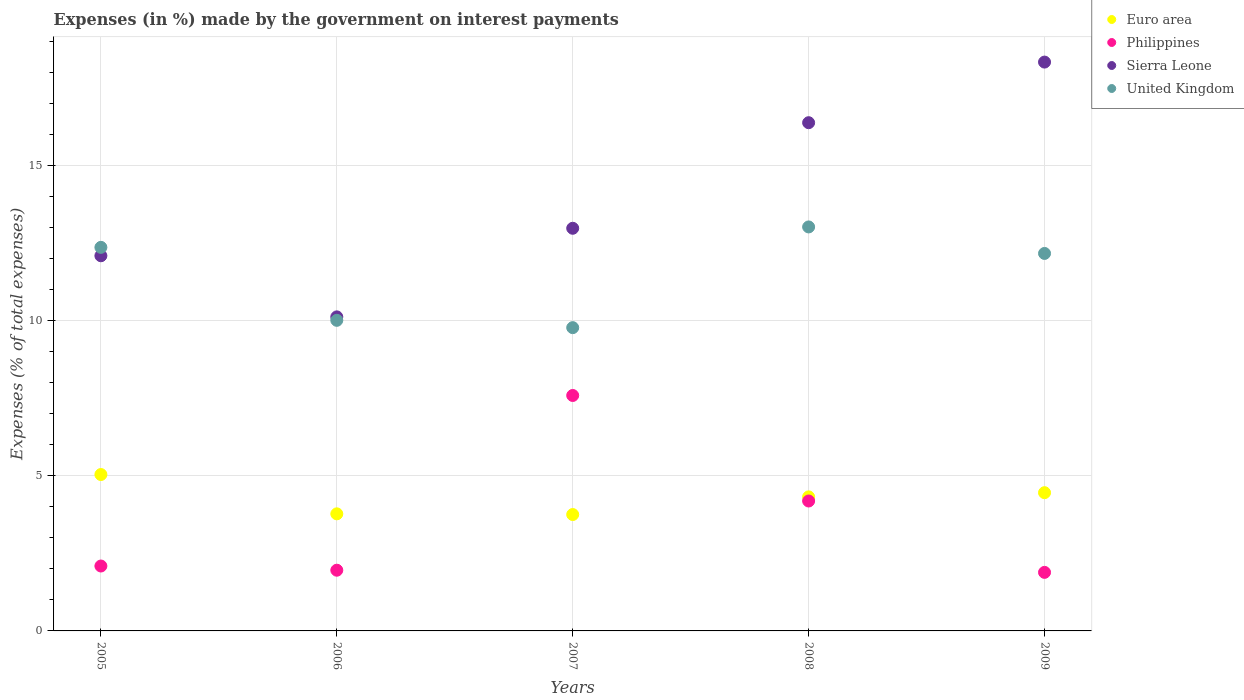What is the percentage of expenses made by the government on interest payments in Sierra Leone in 2007?
Provide a succinct answer. 12.99. Across all years, what is the maximum percentage of expenses made by the government on interest payments in Philippines?
Your answer should be very brief. 7.59. Across all years, what is the minimum percentage of expenses made by the government on interest payments in Euro area?
Offer a very short reply. 3.75. In which year was the percentage of expenses made by the government on interest payments in Philippines maximum?
Give a very brief answer. 2007. In which year was the percentage of expenses made by the government on interest payments in Sierra Leone minimum?
Your answer should be very brief. 2006. What is the total percentage of expenses made by the government on interest payments in Philippines in the graph?
Offer a very short reply. 17.73. What is the difference between the percentage of expenses made by the government on interest payments in Philippines in 2006 and that in 2008?
Ensure brevity in your answer.  -2.23. What is the difference between the percentage of expenses made by the government on interest payments in United Kingdom in 2005 and the percentage of expenses made by the government on interest payments in Sierra Leone in 2007?
Provide a short and direct response. -0.62. What is the average percentage of expenses made by the government on interest payments in Sierra Leone per year?
Offer a terse response. 13.99. In the year 2008, what is the difference between the percentage of expenses made by the government on interest payments in Philippines and percentage of expenses made by the government on interest payments in United Kingdom?
Provide a short and direct response. -8.84. What is the ratio of the percentage of expenses made by the government on interest payments in Sierra Leone in 2006 to that in 2007?
Provide a succinct answer. 0.78. Is the difference between the percentage of expenses made by the government on interest payments in Philippines in 2005 and 2006 greater than the difference between the percentage of expenses made by the government on interest payments in United Kingdom in 2005 and 2006?
Provide a succinct answer. No. What is the difference between the highest and the second highest percentage of expenses made by the government on interest payments in Philippines?
Your answer should be very brief. 3.4. What is the difference between the highest and the lowest percentage of expenses made by the government on interest payments in Euro area?
Provide a short and direct response. 1.29. In how many years, is the percentage of expenses made by the government on interest payments in United Kingdom greater than the average percentage of expenses made by the government on interest payments in United Kingdom taken over all years?
Provide a succinct answer. 3. Is the sum of the percentage of expenses made by the government on interest payments in Euro area in 2006 and 2009 greater than the maximum percentage of expenses made by the government on interest payments in Sierra Leone across all years?
Make the answer very short. No. Is it the case that in every year, the sum of the percentage of expenses made by the government on interest payments in Sierra Leone and percentage of expenses made by the government on interest payments in United Kingdom  is greater than the percentage of expenses made by the government on interest payments in Philippines?
Ensure brevity in your answer.  Yes. Does the percentage of expenses made by the government on interest payments in Sierra Leone monotonically increase over the years?
Provide a short and direct response. No. Is the percentage of expenses made by the government on interest payments in Sierra Leone strictly greater than the percentage of expenses made by the government on interest payments in Philippines over the years?
Give a very brief answer. Yes. How many years are there in the graph?
Keep it short and to the point. 5. Are the values on the major ticks of Y-axis written in scientific E-notation?
Your answer should be very brief. No. Does the graph contain any zero values?
Your response must be concise. No. How are the legend labels stacked?
Ensure brevity in your answer.  Vertical. What is the title of the graph?
Your answer should be compact. Expenses (in %) made by the government on interest payments. Does "Austria" appear as one of the legend labels in the graph?
Provide a short and direct response. No. What is the label or title of the Y-axis?
Your response must be concise. Expenses (% of total expenses). What is the Expenses (% of total expenses) in Euro area in 2005?
Offer a very short reply. 5.04. What is the Expenses (% of total expenses) of Philippines in 2005?
Provide a succinct answer. 2.09. What is the Expenses (% of total expenses) in Sierra Leone in 2005?
Your response must be concise. 12.1. What is the Expenses (% of total expenses) of United Kingdom in 2005?
Make the answer very short. 12.37. What is the Expenses (% of total expenses) of Euro area in 2006?
Offer a very short reply. 3.78. What is the Expenses (% of total expenses) in Philippines in 2006?
Ensure brevity in your answer.  1.96. What is the Expenses (% of total expenses) in Sierra Leone in 2006?
Offer a terse response. 10.13. What is the Expenses (% of total expenses) in United Kingdom in 2006?
Provide a short and direct response. 10.02. What is the Expenses (% of total expenses) of Euro area in 2007?
Offer a terse response. 3.75. What is the Expenses (% of total expenses) of Philippines in 2007?
Provide a succinct answer. 7.59. What is the Expenses (% of total expenses) of Sierra Leone in 2007?
Offer a terse response. 12.99. What is the Expenses (% of total expenses) in United Kingdom in 2007?
Ensure brevity in your answer.  9.78. What is the Expenses (% of total expenses) in Euro area in 2008?
Ensure brevity in your answer.  4.32. What is the Expenses (% of total expenses) in Philippines in 2008?
Provide a succinct answer. 4.19. What is the Expenses (% of total expenses) of Sierra Leone in 2008?
Provide a short and direct response. 16.39. What is the Expenses (% of total expenses) in United Kingdom in 2008?
Give a very brief answer. 13.03. What is the Expenses (% of total expenses) of Euro area in 2009?
Provide a succinct answer. 4.46. What is the Expenses (% of total expenses) of Philippines in 2009?
Provide a succinct answer. 1.89. What is the Expenses (% of total expenses) in Sierra Leone in 2009?
Ensure brevity in your answer.  18.35. What is the Expenses (% of total expenses) of United Kingdom in 2009?
Your response must be concise. 12.18. Across all years, what is the maximum Expenses (% of total expenses) in Euro area?
Your answer should be very brief. 5.04. Across all years, what is the maximum Expenses (% of total expenses) in Philippines?
Make the answer very short. 7.59. Across all years, what is the maximum Expenses (% of total expenses) of Sierra Leone?
Offer a terse response. 18.35. Across all years, what is the maximum Expenses (% of total expenses) in United Kingdom?
Give a very brief answer. 13.03. Across all years, what is the minimum Expenses (% of total expenses) in Euro area?
Your answer should be very brief. 3.75. Across all years, what is the minimum Expenses (% of total expenses) of Philippines?
Make the answer very short. 1.89. Across all years, what is the minimum Expenses (% of total expenses) of Sierra Leone?
Ensure brevity in your answer.  10.13. Across all years, what is the minimum Expenses (% of total expenses) in United Kingdom?
Give a very brief answer. 9.78. What is the total Expenses (% of total expenses) in Euro area in the graph?
Ensure brevity in your answer.  21.36. What is the total Expenses (% of total expenses) of Philippines in the graph?
Provide a short and direct response. 17.73. What is the total Expenses (% of total expenses) of Sierra Leone in the graph?
Your answer should be very brief. 69.96. What is the total Expenses (% of total expenses) of United Kingdom in the graph?
Your response must be concise. 57.38. What is the difference between the Expenses (% of total expenses) in Euro area in 2005 and that in 2006?
Provide a short and direct response. 1.27. What is the difference between the Expenses (% of total expenses) in Philippines in 2005 and that in 2006?
Ensure brevity in your answer.  0.14. What is the difference between the Expenses (% of total expenses) in Sierra Leone in 2005 and that in 2006?
Provide a succinct answer. 1.97. What is the difference between the Expenses (% of total expenses) in United Kingdom in 2005 and that in 2006?
Ensure brevity in your answer.  2.35. What is the difference between the Expenses (% of total expenses) of Euro area in 2005 and that in 2007?
Keep it short and to the point. 1.29. What is the difference between the Expenses (% of total expenses) of Philippines in 2005 and that in 2007?
Ensure brevity in your answer.  -5.5. What is the difference between the Expenses (% of total expenses) of Sierra Leone in 2005 and that in 2007?
Provide a succinct answer. -0.89. What is the difference between the Expenses (% of total expenses) in United Kingdom in 2005 and that in 2007?
Offer a terse response. 2.59. What is the difference between the Expenses (% of total expenses) in Euro area in 2005 and that in 2008?
Ensure brevity in your answer.  0.72. What is the difference between the Expenses (% of total expenses) of Philippines in 2005 and that in 2008?
Your answer should be compact. -2.1. What is the difference between the Expenses (% of total expenses) of Sierra Leone in 2005 and that in 2008?
Give a very brief answer. -4.29. What is the difference between the Expenses (% of total expenses) of United Kingdom in 2005 and that in 2008?
Ensure brevity in your answer.  -0.66. What is the difference between the Expenses (% of total expenses) in Euro area in 2005 and that in 2009?
Offer a terse response. 0.59. What is the difference between the Expenses (% of total expenses) in Philippines in 2005 and that in 2009?
Offer a very short reply. 0.2. What is the difference between the Expenses (% of total expenses) in Sierra Leone in 2005 and that in 2009?
Your response must be concise. -6.25. What is the difference between the Expenses (% of total expenses) in United Kingdom in 2005 and that in 2009?
Give a very brief answer. 0.2. What is the difference between the Expenses (% of total expenses) of Euro area in 2006 and that in 2007?
Ensure brevity in your answer.  0.02. What is the difference between the Expenses (% of total expenses) in Philippines in 2006 and that in 2007?
Your answer should be very brief. -5.64. What is the difference between the Expenses (% of total expenses) in Sierra Leone in 2006 and that in 2007?
Ensure brevity in your answer.  -2.86. What is the difference between the Expenses (% of total expenses) in United Kingdom in 2006 and that in 2007?
Provide a succinct answer. 0.24. What is the difference between the Expenses (% of total expenses) in Euro area in 2006 and that in 2008?
Your answer should be very brief. -0.55. What is the difference between the Expenses (% of total expenses) of Philippines in 2006 and that in 2008?
Your answer should be compact. -2.23. What is the difference between the Expenses (% of total expenses) in Sierra Leone in 2006 and that in 2008?
Provide a short and direct response. -6.26. What is the difference between the Expenses (% of total expenses) of United Kingdom in 2006 and that in 2008?
Offer a very short reply. -3.01. What is the difference between the Expenses (% of total expenses) in Euro area in 2006 and that in 2009?
Keep it short and to the point. -0.68. What is the difference between the Expenses (% of total expenses) of Philippines in 2006 and that in 2009?
Offer a terse response. 0.07. What is the difference between the Expenses (% of total expenses) in Sierra Leone in 2006 and that in 2009?
Your answer should be compact. -8.22. What is the difference between the Expenses (% of total expenses) in United Kingdom in 2006 and that in 2009?
Keep it short and to the point. -2.16. What is the difference between the Expenses (% of total expenses) of Euro area in 2007 and that in 2008?
Make the answer very short. -0.57. What is the difference between the Expenses (% of total expenses) of Philippines in 2007 and that in 2008?
Offer a terse response. 3.4. What is the difference between the Expenses (% of total expenses) in Sierra Leone in 2007 and that in 2008?
Make the answer very short. -3.41. What is the difference between the Expenses (% of total expenses) of United Kingdom in 2007 and that in 2008?
Your answer should be compact. -3.25. What is the difference between the Expenses (% of total expenses) of Euro area in 2007 and that in 2009?
Provide a succinct answer. -0.7. What is the difference between the Expenses (% of total expenses) in Philippines in 2007 and that in 2009?
Offer a very short reply. 5.71. What is the difference between the Expenses (% of total expenses) of Sierra Leone in 2007 and that in 2009?
Make the answer very short. -5.36. What is the difference between the Expenses (% of total expenses) of United Kingdom in 2007 and that in 2009?
Provide a succinct answer. -2.39. What is the difference between the Expenses (% of total expenses) of Euro area in 2008 and that in 2009?
Provide a short and direct response. -0.13. What is the difference between the Expenses (% of total expenses) in Philippines in 2008 and that in 2009?
Your answer should be compact. 2.3. What is the difference between the Expenses (% of total expenses) of Sierra Leone in 2008 and that in 2009?
Give a very brief answer. -1.96. What is the difference between the Expenses (% of total expenses) in United Kingdom in 2008 and that in 2009?
Your answer should be compact. 0.85. What is the difference between the Expenses (% of total expenses) of Euro area in 2005 and the Expenses (% of total expenses) of Philippines in 2006?
Your answer should be very brief. 3.09. What is the difference between the Expenses (% of total expenses) of Euro area in 2005 and the Expenses (% of total expenses) of Sierra Leone in 2006?
Your answer should be compact. -5.09. What is the difference between the Expenses (% of total expenses) of Euro area in 2005 and the Expenses (% of total expenses) of United Kingdom in 2006?
Offer a terse response. -4.97. What is the difference between the Expenses (% of total expenses) in Philippines in 2005 and the Expenses (% of total expenses) in Sierra Leone in 2006?
Offer a terse response. -8.04. What is the difference between the Expenses (% of total expenses) of Philippines in 2005 and the Expenses (% of total expenses) of United Kingdom in 2006?
Ensure brevity in your answer.  -7.92. What is the difference between the Expenses (% of total expenses) in Sierra Leone in 2005 and the Expenses (% of total expenses) in United Kingdom in 2006?
Offer a terse response. 2.08. What is the difference between the Expenses (% of total expenses) of Euro area in 2005 and the Expenses (% of total expenses) of Philippines in 2007?
Ensure brevity in your answer.  -2.55. What is the difference between the Expenses (% of total expenses) in Euro area in 2005 and the Expenses (% of total expenses) in Sierra Leone in 2007?
Give a very brief answer. -7.94. What is the difference between the Expenses (% of total expenses) of Euro area in 2005 and the Expenses (% of total expenses) of United Kingdom in 2007?
Ensure brevity in your answer.  -4.74. What is the difference between the Expenses (% of total expenses) of Philippines in 2005 and the Expenses (% of total expenses) of Sierra Leone in 2007?
Keep it short and to the point. -10.89. What is the difference between the Expenses (% of total expenses) of Philippines in 2005 and the Expenses (% of total expenses) of United Kingdom in 2007?
Keep it short and to the point. -7.69. What is the difference between the Expenses (% of total expenses) of Sierra Leone in 2005 and the Expenses (% of total expenses) of United Kingdom in 2007?
Your answer should be very brief. 2.32. What is the difference between the Expenses (% of total expenses) of Euro area in 2005 and the Expenses (% of total expenses) of Philippines in 2008?
Offer a very short reply. 0.85. What is the difference between the Expenses (% of total expenses) in Euro area in 2005 and the Expenses (% of total expenses) in Sierra Leone in 2008?
Ensure brevity in your answer.  -11.35. What is the difference between the Expenses (% of total expenses) of Euro area in 2005 and the Expenses (% of total expenses) of United Kingdom in 2008?
Your response must be concise. -7.99. What is the difference between the Expenses (% of total expenses) in Philippines in 2005 and the Expenses (% of total expenses) in Sierra Leone in 2008?
Make the answer very short. -14.3. What is the difference between the Expenses (% of total expenses) in Philippines in 2005 and the Expenses (% of total expenses) in United Kingdom in 2008?
Your response must be concise. -10.94. What is the difference between the Expenses (% of total expenses) in Sierra Leone in 2005 and the Expenses (% of total expenses) in United Kingdom in 2008?
Ensure brevity in your answer.  -0.93. What is the difference between the Expenses (% of total expenses) in Euro area in 2005 and the Expenses (% of total expenses) in Philippines in 2009?
Offer a very short reply. 3.16. What is the difference between the Expenses (% of total expenses) of Euro area in 2005 and the Expenses (% of total expenses) of Sierra Leone in 2009?
Make the answer very short. -13.3. What is the difference between the Expenses (% of total expenses) of Euro area in 2005 and the Expenses (% of total expenses) of United Kingdom in 2009?
Make the answer very short. -7.13. What is the difference between the Expenses (% of total expenses) of Philippines in 2005 and the Expenses (% of total expenses) of Sierra Leone in 2009?
Make the answer very short. -16.25. What is the difference between the Expenses (% of total expenses) in Philippines in 2005 and the Expenses (% of total expenses) in United Kingdom in 2009?
Offer a very short reply. -10.08. What is the difference between the Expenses (% of total expenses) in Sierra Leone in 2005 and the Expenses (% of total expenses) in United Kingdom in 2009?
Offer a very short reply. -0.07. What is the difference between the Expenses (% of total expenses) of Euro area in 2006 and the Expenses (% of total expenses) of Philippines in 2007?
Give a very brief answer. -3.82. What is the difference between the Expenses (% of total expenses) in Euro area in 2006 and the Expenses (% of total expenses) in Sierra Leone in 2007?
Your answer should be compact. -9.21. What is the difference between the Expenses (% of total expenses) of Euro area in 2006 and the Expenses (% of total expenses) of United Kingdom in 2007?
Your answer should be compact. -6.01. What is the difference between the Expenses (% of total expenses) of Philippines in 2006 and the Expenses (% of total expenses) of Sierra Leone in 2007?
Provide a short and direct response. -11.03. What is the difference between the Expenses (% of total expenses) of Philippines in 2006 and the Expenses (% of total expenses) of United Kingdom in 2007?
Make the answer very short. -7.82. What is the difference between the Expenses (% of total expenses) of Sierra Leone in 2006 and the Expenses (% of total expenses) of United Kingdom in 2007?
Your answer should be very brief. 0.35. What is the difference between the Expenses (% of total expenses) of Euro area in 2006 and the Expenses (% of total expenses) of Philippines in 2008?
Provide a short and direct response. -0.41. What is the difference between the Expenses (% of total expenses) in Euro area in 2006 and the Expenses (% of total expenses) in Sierra Leone in 2008?
Keep it short and to the point. -12.62. What is the difference between the Expenses (% of total expenses) in Euro area in 2006 and the Expenses (% of total expenses) in United Kingdom in 2008?
Offer a very short reply. -9.25. What is the difference between the Expenses (% of total expenses) in Philippines in 2006 and the Expenses (% of total expenses) in Sierra Leone in 2008?
Ensure brevity in your answer.  -14.43. What is the difference between the Expenses (% of total expenses) in Philippines in 2006 and the Expenses (% of total expenses) in United Kingdom in 2008?
Give a very brief answer. -11.07. What is the difference between the Expenses (% of total expenses) of Sierra Leone in 2006 and the Expenses (% of total expenses) of United Kingdom in 2008?
Make the answer very short. -2.9. What is the difference between the Expenses (% of total expenses) of Euro area in 2006 and the Expenses (% of total expenses) of Philippines in 2009?
Give a very brief answer. 1.89. What is the difference between the Expenses (% of total expenses) in Euro area in 2006 and the Expenses (% of total expenses) in Sierra Leone in 2009?
Your answer should be very brief. -14.57. What is the difference between the Expenses (% of total expenses) of Euro area in 2006 and the Expenses (% of total expenses) of United Kingdom in 2009?
Your answer should be very brief. -8.4. What is the difference between the Expenses (% of total expenses) in Philippines in 2006 and the Expenses (% of total expenses) in Sierra Leone in 2009?
Give a very brief answer. -16.39. What is the difference between the Expenses (% of total expenses) of Philippines in 2006 and the Expenses (% of total expenses) of United Kingdom in 2009?
Your answer should be very brief. -10.22. What is the difference between the Expenses (% of total expenses) of Sierra Leone in 2006 and the Expenses (% of total expenses) of United Kingdom in 2009?
Provide a short and direct response. -2.05. What is the difference between the Expenses (% of total expenses) in Euro area in 2007 and the Expenses (% of total expenses) in Philippines in 2008?
Offer a terse response. -0.44. What is the difference between the Expenses (% of total expenses) of Euro area in 2007 and the Expenses (% of total expenses) of Sierra Leone in 2008?
Your answer should be very brief. -12.64. What is the difference between the Expenses (% of total expenses) of Euro area in 2007 and the Expenses (% of total expenses) of United Kingdom in 2008?
Make the answer very short. -9.28. What is the difference between the Expenses (% of total expenses) of Philippines in 2007 and the Expenses (% of total expenses) of Sierra Leone in 2008?
Keep it short and to the point. -8.8. What is the difference between the Expenses (% of total expenses) of Philippines in 2007 and the Expenses (% of total expenses) of United Kingdom in 2008?
Your answer should be very brief. -5.44. What is the difference between the Expenses (% of total expenses) in Sierra Leone in 2007 and the Expenses (% of total expenses) in United Kingdom in 2008?
Your response must be concise. -0.04. What is the difference between the Expenses (% of total expenses) of Euro area in 2007 and the Expenses (% of total expenses) of Philippines in 2009?
Make the answer very short. 1.87. What is the difference between the Expenses (% of total expenses) of Euro area in 2007 and the Expenses (% of total expenses) of Sierra Leone in 2009?
Your answer should be very brief. -14.59. What is the difference between the Expenses (% of total expenses) in Euro area in 2007 and the Expenses (% of total expenses) in United Kingdom in 2009?
Keep it short and to the point. -8.42. What is the difference between the Expenses (% of total expenses) in Philippines in 2007 and the Expenses (% of total expenses) in Sierra Leone in 2009?
Make the answer very short. -10.75. What is the difference between the Expenses (% of total expenses) of Philippines in 2007 and the Expenses (% of total expenses) of United Kingdom in 2009?
Give a very brief answer. -4.58. What is the difference between the Expenses (% of total expenses) of Sierra Leone in 2007 and the Expenses (% of total expenses) of United Kingdom in 2009?
Offer a terse response. 0.81. What is the difference between the Expenses (% of total expenses) of Euro area in 2008 and the Expenses (% of total expenses) of Philippines in 2009?
Make the answer very short. 2.44. What is the difference between the Expenses (% of total expenses) in Euro area in 2008 and the Expenses (% of total expenses) in Sierra Leone in 2009?
Ensure brevity in your answer.  -14.02. What is the difference between the Expenses (% of total expenses) of Euro area in 2008 and the Expenses (% of total expenses) of United Kingdom in 2009?
Your answer should be compact. -7.85. What is the difference between the Expenses (% of total expenses) of Philippines in 2008 and the Expenses (% of total expenses) of Sierra Leone in 2009?
Give a very brief answer. -14.16. What is the difference between the Expenses (% of total expenses) of Philippines in 2008 and the Expenses (% of total expenses) of United Kingdom in 2009?
Offer a very short reply. -7.99. What is the difference between the Expenses (% of total expenses) in Sierra Leone in 2008 and the Expenses (% of total expenses) in United Kingdom in 2009?
Provide a succinct answer. 4.22. What is the average Expenses (% of total expenses) of Euro area per year?
Provide a short and direct response. 4.27. What is the average Expenses (% of total expenses) of Philippines per year?
Provide a succinct answer. 3.55. What is the average Expenses (% of total expenses) in Sierra Leone per year?
Offer a terse response. 13.99. What is the average Expenses (% of total expenses) in United Kingdom per year?
Give a very brief answer. 11.48. In the year 2005, what is the difference between the Expenses (% of total expenses) of Euro area and Expenses (% of total expenses) of Philippines?
Offer a terse response. 2.95. In the year 2005, what is the difference between the Expenses (% of total expenses) of Euro area and Expenses (% of total expenses) of Sierra Leone?
Your answer should be very brief. -7.06. In the year 2005, what is the difference between the Expenses (% of total expenses) in Euro area and Expenses (% of total expenses) in United Kingdom?
Provide a succinct answer. -7.33. In the year 2005, what is the difference between the Expenses (% of total expenses) in Philippines and Expenses (% of total expenses) in Sierra Leone?
Ensure brevity in your answer.  -10.01. In the year 2005, what is the difference between the Expenses (% of total expenses) in Philippines and Expenses (% of total expenses) in United Kingdom?
Your answer should be compact. -10.28. In the year 2005, what is the difference between the Expenses (% of total expenses) in Sierra Leone and Expenses (% of total expenses) in United Kingdom?
Provide a succinct answer. -0.27. In the year 2006, what is the difference between the Expenses (% of total expenses) in Euro area and Expenses (% of total expenses) in Philippines?
Give a very brief answer. 1.82. In the year 2006, what is the difference between the Expenses (% of total expenses) in Euro area and Expenses (% of total expenses) in Sierra Leone?
Provide a short and direct response. -6.35. In the year 2006, what is the difference between the Expenses (% of total expenses) in Euro area and Expenses (% of total expenses) in United Kingdom?
Provide a succinct answer. -6.24. In the year 2006, what is the difference between the Expenses (% of total expenses) in Philippines and Expenses (% of total expenses) in Sierra Leone?
Your answer should be compact. -8.17. In the year 2006, what is the difference between the Expenses (% of total expenses) of Philippines and Expenses (% of total expenses) of United Kingdom?
Your response must be concise. -8.06. In the year 2006, what is the difference between the Expenses (% of total expenses) of Sierra Leone and Expenses (% of total expenses) of United Kingdom?
Provide a succinct answer. 0.11. In the year 2007, what is the difference between the Expenses (% of total expenses) of Euro area and Expenses (% of total expenses) of Philippines?
Ensure brevity in your answer.  -3.84. In the year 2007, what is the difference between the Expenses (% of total expenses) in Euro area and Expenses (% of total expenses) in Sierra Leone?
Your answer should be compact. -9.23. In the year 2007, what is the difference between the Expenses (% of total expenses) of Euro area and Expenses (% of total expenses) of United Kingdom?
Keep it short and to the point. -6.03. In the year 2007, what is the difference between the Expenses (% of total expenses) of Philippines and Expenses (% of total expenses) of Sierra Leone?
Provide a short and direct response. -5.39. In the year 2007, what is the difference between the Expenses (% of total expenses) in Philippines and Expenses (% of total expenses) in United Kingdom?
Give a very brief answer. -2.19. In the year 2007, what is the difference between the Expenses (% of total expenses) of Sierra Leone and Expenses (% of total expenses) of United Kingdom?
Ensure brevity in your answer.  3.21. In the year 2008, what is the difference between the Expenses (% of total expenses) in Euro area and Expenses (% of total expenses) in Philippines?
Make the answer very short. 0.13. In the year 2008, what is the difference between the Expenses (% of total expenses) of Euro area and Expenses (% of total expenses) of Sierra Leone?
Give a very brief answer. -12.07. In the year 2008, what is the difference between the Expenses (% of total expenses) in Euro area and Expenses (% of total expenses) in United Kingdom?
Offer a terse response. -8.71. In the year 2008, what is the difference between the Expenses (% of total expenses) of Philippines and Expenses (% of total expenses) of Sierra Leone?
Make the answer very short. -12.2. In the year 2008, what is the difference between the Expenses (% of total expenses) in Philippines and Expenses (% of total expenses) in United Kingdom?
Give a very brief answer. -8.84. In the year 2008, what is the difference between the Expenses (% of total expenses) in Sierra Leone and Expenses (% of total expenses) in United Kingdom?
Offer a very short reply. 3.36. In the year 2009, what is the difference between the Expenses (% of total expenses) in Euro area and Expenses (% of total expenses) in Philippines?
Your answer should be very brief. 2.57. In the year 2009, what is the difference between the Expenses (% of total expenses) of Euro area and Expenses (% of total expenses) of Sierra Leone?
Make the answer very short. -13.89. In the year 2009, what is the difference between the Expenses (% of total expenses) of Euro area and Expenses (% of total expenses) of United Kingdom?
Keep it short and to the point. -7.72. In the year 2009, what is the difference between the Expenses (% of total expenses) of Philippines and Expenses (% of total expenses) of Sierra Leone?
Make the answer very short. -16.46. In the year 2009, what is the difference between the Expenses (% of total expenses) in Philippines and Expenses (% of total expenses) in United Kingdom?
Make the answer very short. -10.29. In the year 2009, what is the difference between the Expenses (% of total expenses) of Sierra Leone and Expenses (% of total expenses) of United Kingdom?
Offer a very short reply. 6.17. What is the ratio of the Expenses (% of total expenses) of Euro area in 2005 to that in 2006?
Your answer should be compact. 1.34. What is the ratio of the Expenses (% of total expenses) of Philippines in 2005 to that in 2006?
Offer a terse response. 1.07. What is the ratio of the Expenses (% of total expenses) in Sierra Leone in 2005 to that in 2006?
Your answer should be compact. 1.19. What is the ratio of the Expenses (% of total expenses) of United Kingdom in 2005 to that in 2006?
Your answer should be very brief. 1.23. What is the ratio of the Expenses (% of total expenses) of Euro area in 2005 to that in 2007?
Your answer should be compact. 1.34. What is the ratio of the Expenses (% of total expenses) of Philippines in 2005 to that in 2007?
Make the answer very short. 0.28. What is the ratio of the Expenses (% of total expenses) in Sierra Leone in 2005 to that in 2007?
Offer a very short reply. 0.93. What is the ratio of the Expenses (% of total expenses) of United Kingdom in 2005 to that in 2007?
Offer a terse response. 1.26. What is the ratio of the Expenses (% of total expenses) of Euro area in 2005 to that in 2008?
Your answer should be compact. 1.17. What is the ratio of the Expenses (% of total expenses) in Philippines in 2005 to that in 2008?
Offer a terse response. 0.5. What is the ratio of the Expenses (% of total expenses) in Sierra Leone in 2005 to that in 2008?
Your response must be concise. 0.74. What is the ratio of the Expenses (% of total expenses) of United Kingdom in 2005 to that in 2008?
Give a very brief answer. 0.95. What is the ratio of the Expenses (% of total expenses) in Euro area in 2005 to that in 2009?
Your response must be concise. 1.13. What is the ratio of the Expenses (% of total expenses) in Philippines in 2005 to that in 2009?
Provide a short and direct response. 1.11. What is the ratio of the Expenses (% of total expenses) of Sierra Leone in 2005 to that in 2009?
Your answer should be compact. 0.66. What is the ratio of the Expenses (% of total expenses) of United Kingdom in 2005 to that in 2009?
Provide a short and direct response. 1.02. What is the ratio of the Expenses (% of total expenses) of Philippines in 2006 to that in 2007?
Your answer should be very brief. 0.26. What is the ratio of the Expenses (% of total expenses) of Sierra Leone in 2006 to that in 2007?
Your answer should be very brief. 0.78. What is the ratio of the Expenses (% of total expenses) in United Kingdom in 2006 to that in 2007?
Ensure brevity in your answer.  1.02. What is the ratio of the Expenses (% of total expenses) of Euro area in 2006 to that in 2008?
Offer a very short reply. 0.87. What is the ratio of the Expenses (% of total expenses) in Philippines in 2006 to that in 2008?
Ensure brevity in your answer.  0.47. What is the ratio of the Expenses (% of total expenses) in Sierra Leone in 2006 to that in 2008?
Ensure brevity in your answer.  0.62. What is the ratio of the Expenses (% of total expenses) of United Kingdom in 2006 to that in 2008?
Offer a terse response. 0.77. What is the ratio of the Expenses (% of total expenses) in Euro area in 2006 to that in 2009?
Your answer should be compact. 0.85. What is the ratio of the Expenses (% of total expenses) of Sierra Leone in 2006 to that in 2009?
Offer a terse response. 0.55. What is the ratio of the Expenses (% of total expenses) in United Kingdom in 2006 to that in 2009?
Provide a short and direct response. 0.82. What is the ratio of the Expenses (% of total expenses) in Euro area in 2007 to that in 2008?
Provide a short and direct response. 0.87. What is the ratio of the Expenses (% of total expenses) in Philippines in 2007 to that in 2008?
Offer a terse response. 1.81. What is the ratio of the Expenses (% of total expenses) of Sierra Leone in 2007 to that in 2008?
Your answer should be very brief. 0.79. What is the ratio of the Expenses (% of total expenses) in United Kingdom in 2007 to that in 2008?
Give a very brief answer. 0.75. What is the ratio of the Expenses (% of total expenses) of Euro area in 2007 to that in 2009?
Offer a very short reply. 0.84. What is the ratio of the Expenses (% of total expenses) in Philippines in 2007 to that in 2009?
Provide a succinct answer. 4.02. What is the ratio of the Expenses (% of total expenses) in Sierra Leone in 2007 to that in 2009?
Keep it short and to the point. 0.71. What is the ratio of the Expenses (% of total expenses) of United Kingdom in 2007 to that in 2009?
Provide a short and direct response. 0.8. What is the ratio of the Expenses (% of total expenses) of Euro area in 2008 to that in 2009?
Your response must be concise. 0.97. What is the ratio of the Expenses (% of total expenses) of Philippines in 2008 to that in 2009?
Offer a terse response. 2.22. What is the ratio of the Expenses (% of total expenses) in Sierra Leone in 2008 to that in 2009?
Make the answer very short. 0.89. What is the ratio of the Expenses (% of total expenses) of United Kingdom in 2008 to that in 2009?
Offer a very short reply. 1.07. What is the difference between the highest and the second highest Expenses (% of total expenses) of Euro area?
Your answer should be compact. 0.59. What is the difference between the highest and the second highest Expenses (% of total expenses) in Philippines?
Offer a terse response. 3.4. What is the difference between the highest and the second highest Expenses (% of total expenses) of Sierra Leone?
Provide a short and direct response. 1.96. What is the difference between the highest and the second highest Expenses (% of total expenses) in United Kingdom?
Keep it short and to the point. 0.66. What is the difference between the highest and the lowest Expenses (% of total expenses) in Euro area?
Keep it short and to the point. 1.29. What is the difference between the highest and the lowest Expenses (% of total expenses) in Philippines?
Your response must be concise. 5.71. What is the difference between the highest and the lowest Expenses (% of total expenses) in Sierra Leone?
Make the answer very short. 8.22. What is the difference between the highest and the lowest Expenses (% of total expenses) in United Kingdom?
Your answer should be compact. 3.25. 